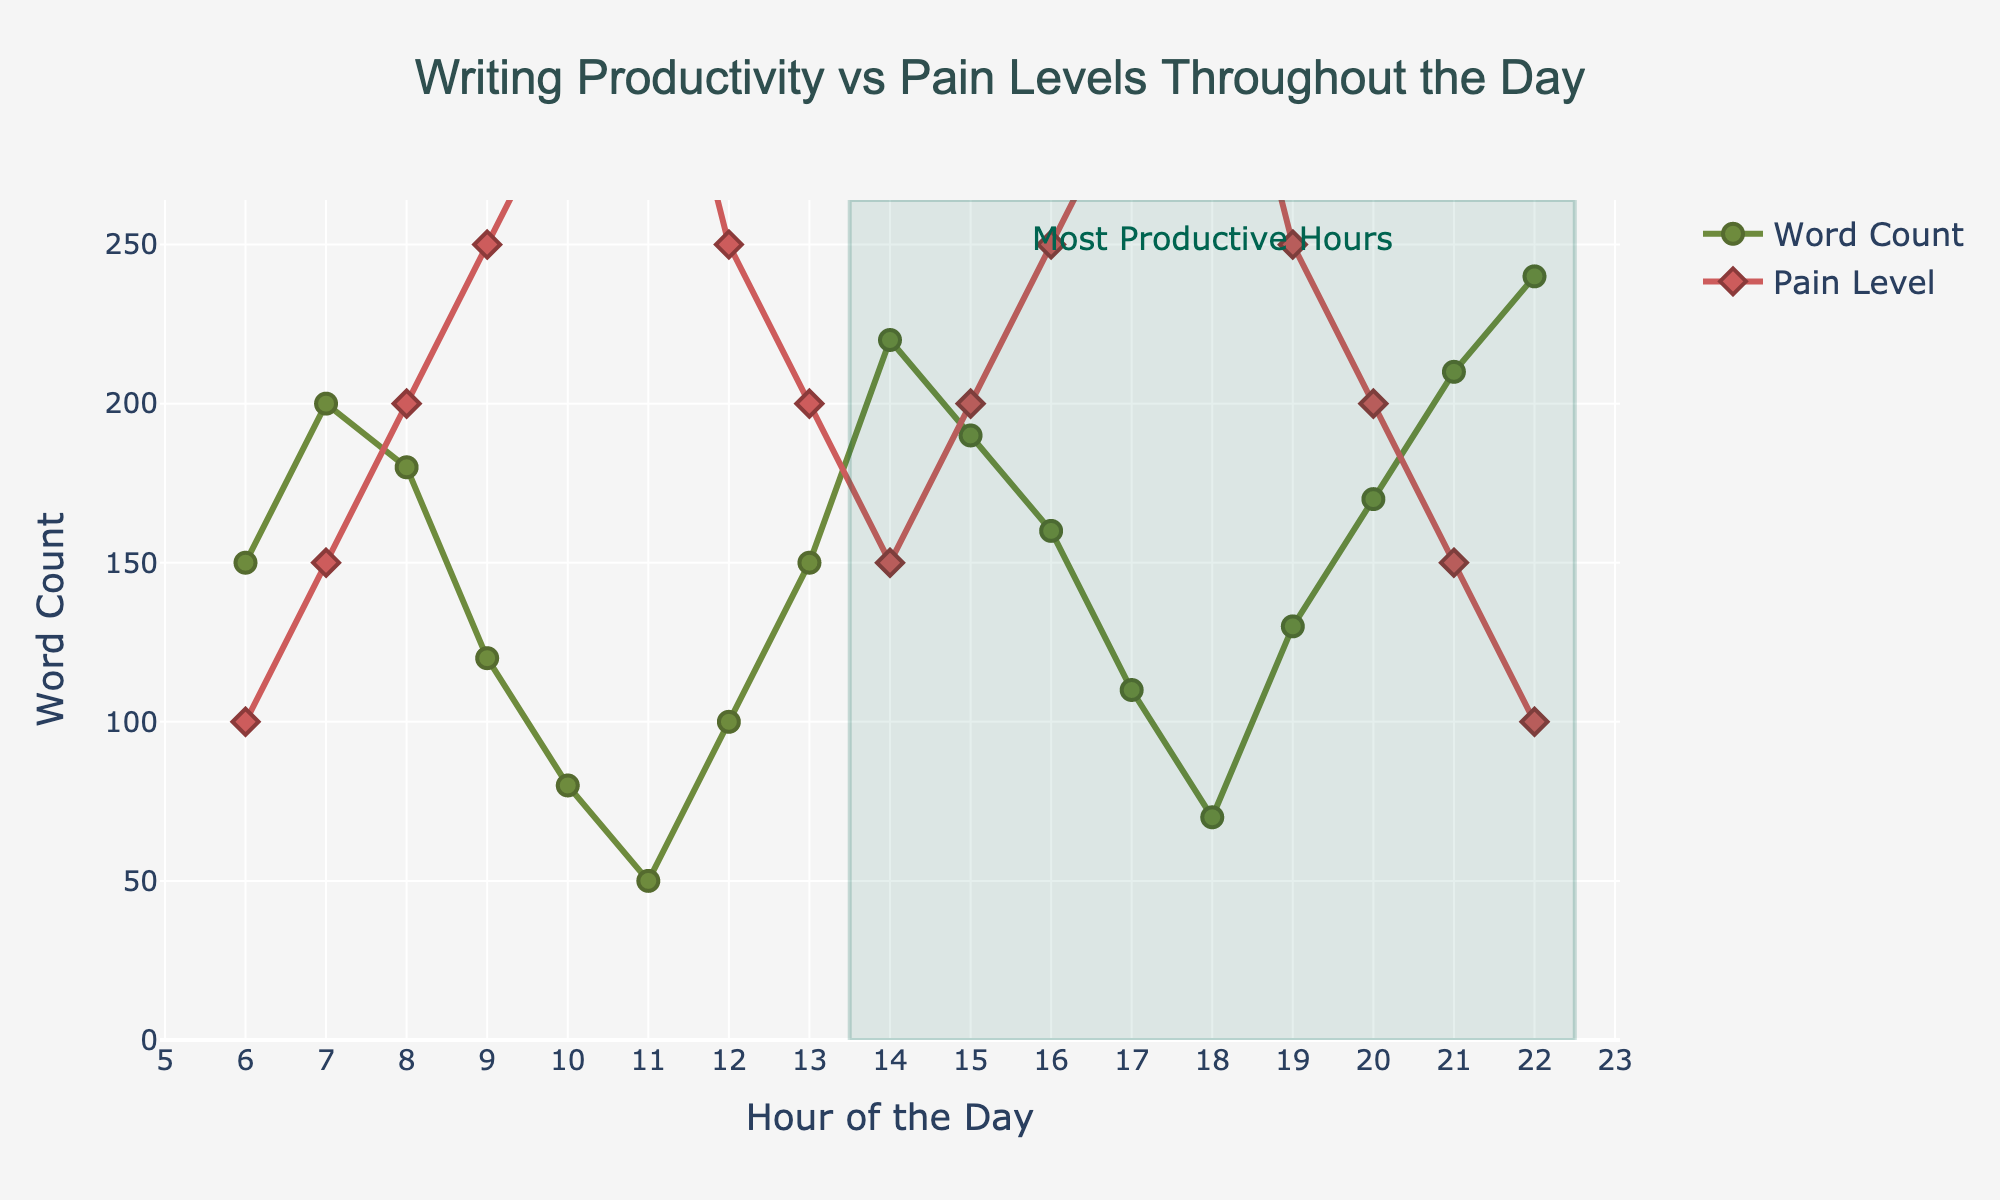What's the title of the plot? The title is positioned at the top center of the figure, which summarizes the primary focus of the data presented.
Answer: Writing Productivity vs Pain Levels Throughout the Day What is the Pain Level at 10 AM and how does it compare to the Pain Level at 1 PM? At 10 AM, the Pain Level is 6 and at 1 PM, it is 4. Comparing these, the Pain Level decreases by 2 units from 10 AM to 1 PM.
Answer: Decreases by 2 Which hour has the highest Word Count, and what is that count? By examining the highest point on the 'Word Count' line, we identify the peak Word Count at 10 PM, which is 240 words.
Answer: 10 PM, 240 words Between which hours is the Word Count within the shaded rectangle, indicating the most productive hours? The shaded rectangle starts at 1:30 PM and ends at 10:30 PM.
Answer: From 2 PM to 10 PM What trend can be observed in Pain Levels from 6 AM to 11 AM? The Pain Levels show a consistent increasing trend from 2 at 6 AM to 7 at 11 AM. This upward progression is depicted by the red line with diamond markers.
Answer: Increasing trend How does the Word Count at 8 AM compare to that at 8 PM? Comparing the heights of the markers, the Word Count at 8 AM is 180, while at 8 PM it is 170, indicating the Word Count at 8 AM is slightly higher than at 8 PM by 10 words.
Answer: Higher by 10 words What is the average Word Count between 3 PM and 5 PM? Summing the Word Count values at 3 PM (190), 4 PM (160), and 5 PM (110), we get 460. Dividing this by the 3 hours gives an average of roughly 153.3 words per hour.
Answer: 153.3 words During which hours do we observe the highest combined Pain Level and Word Count? By examining the overlap of high values on both the lines, it appears from 9 PM (Pain Level 5, Word Count 210) to 10 PM (Pain Level 4, Word Count 240) shows the highest combined values.
Answer: 9 PM to 10 PM What is the difference in Pain Level and Word Count from 6 PM to 7 PM? The Pain Level increases from 6 to 7 (difference of 1) and the Word Count decreases from 110 to 70 (difference of 40).
Answer: Pain Level +1, Word Count -40 